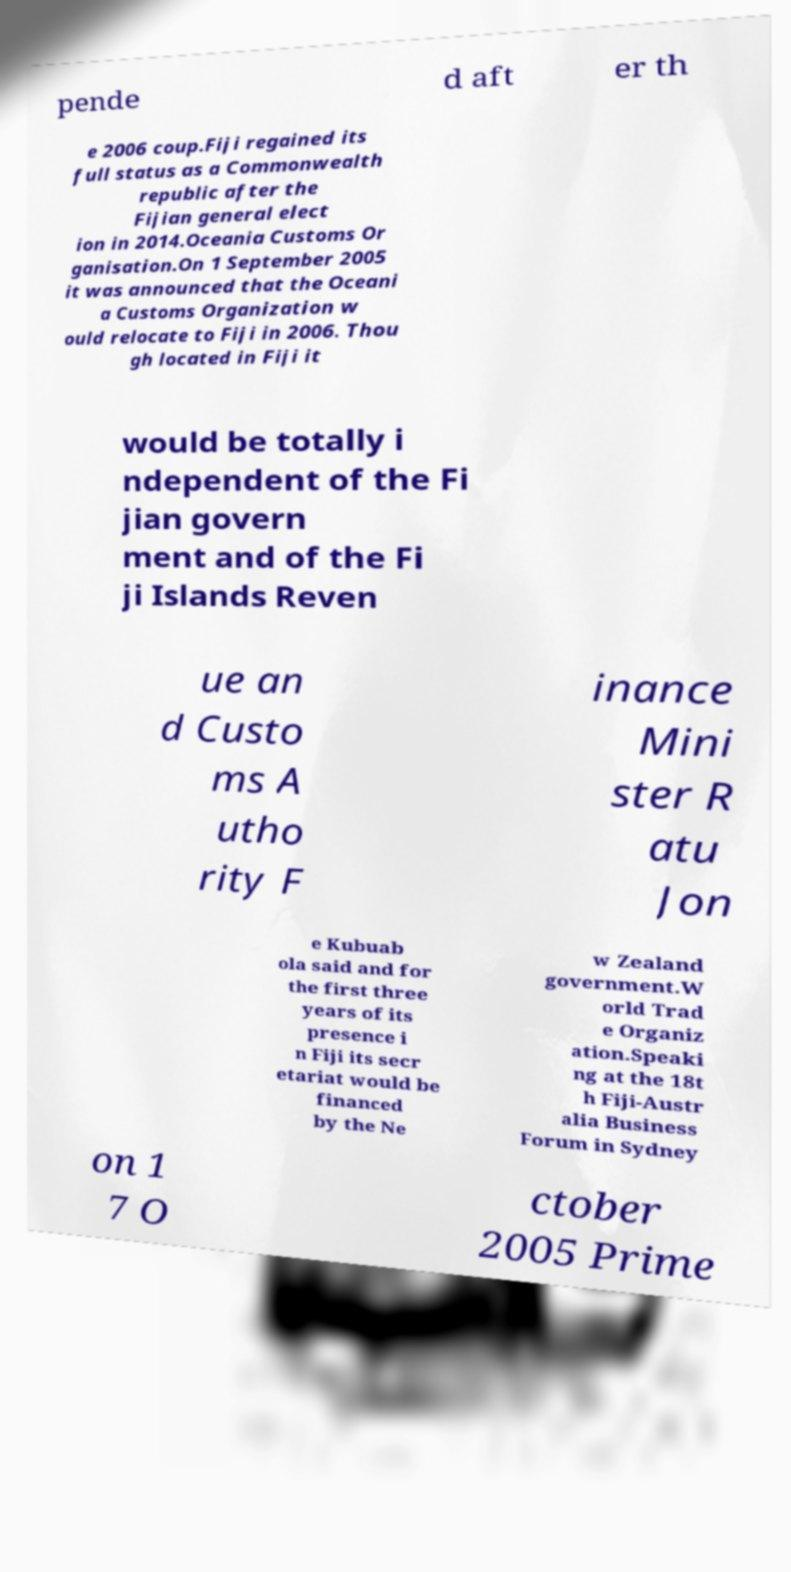For documentation purposes, I need the text within this image transcribed. Could you provide that? pende d aft er th e 2006 coup.Fiji regained its full status as a Commonwealth republic after the Fijian general elect ion in 2014.Oceania Customs Or ganisation.On 1 September 2005 it was announced that the Oceani a Customs Organization w ould relocate to Fiji in 2006. Thou gh located in Fiji it would be totally i ndependent of the Fi jian govern ment and of the Fi ji Islands Reven ue an d Custo ms A utho rity F inance Mini ster R atu Jon e Kubuab ola said and for the first three years of its presence i n Fiji its secr etariat would be financed by the Ne w Zealand government.W orld Trad e Organiz ation.Speaki ng at the 18t h Fiji-Austr alia Business Forum in Sydney on 1 7 O ctober 2005 Prime 